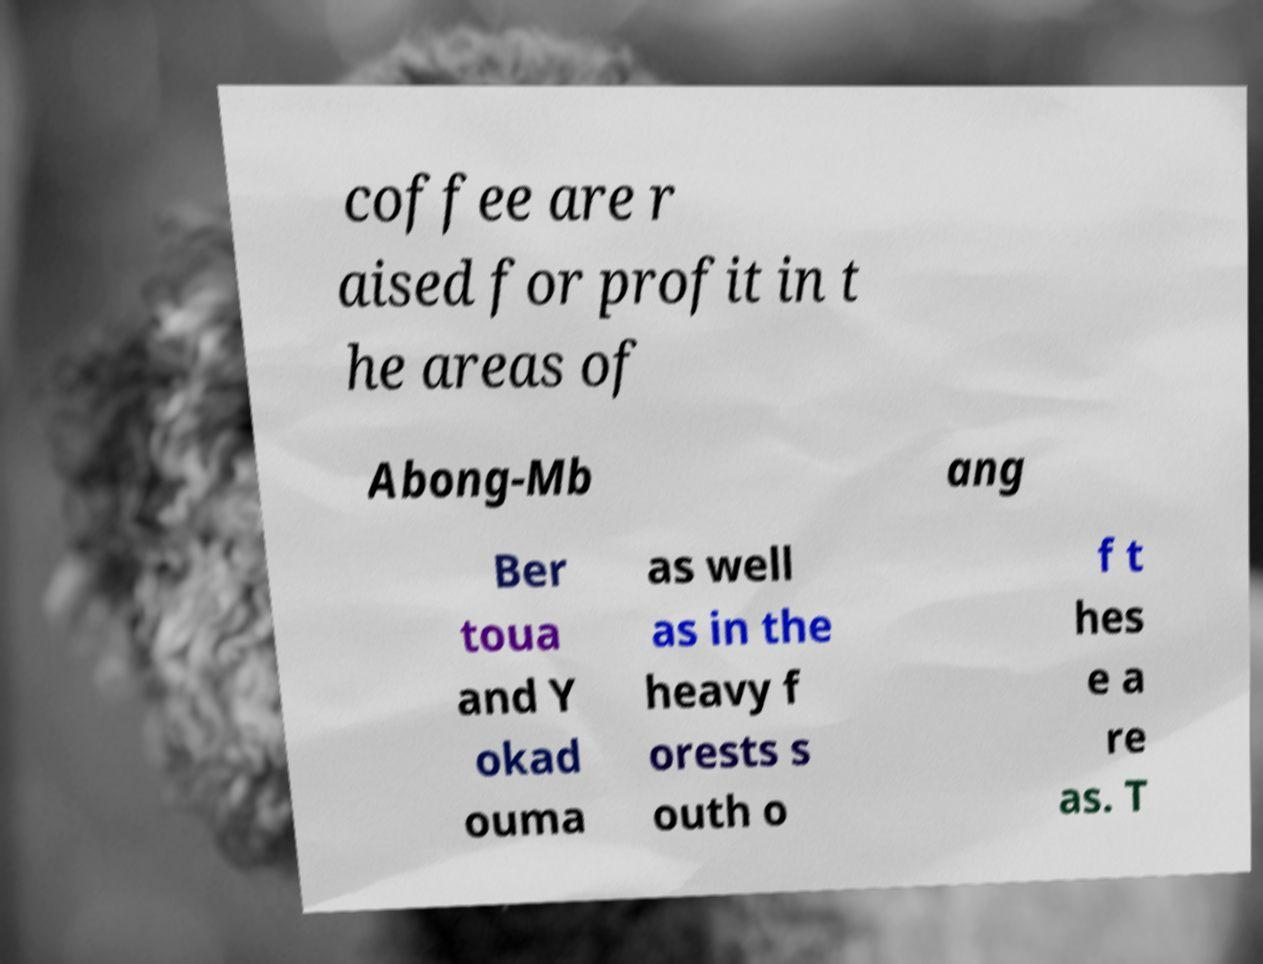There's text embedded in this image that I need extracted. Can you transcribe it verbatim? coffee are r aised for profit in t he areas of Abong-Mb ang Ber toua and Y okad ouma as well as in the heavy f orests s outh o f t hes e a re as. T 